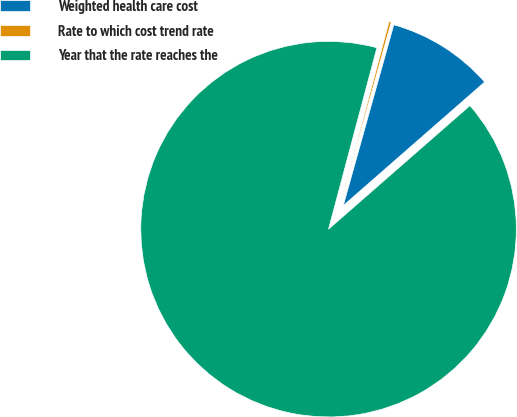Convert chart to OTSL. <chart><loc_0><loc_0><loc_500><loc_500><pie_chart><fcel>Weighted health care cost<fcel>Rate to which cost trend rate<fcel>Year that the rate reaches the<nl><fcel>9.23%<fcel>0.19%<fcel>90.57%<nl></chart> 